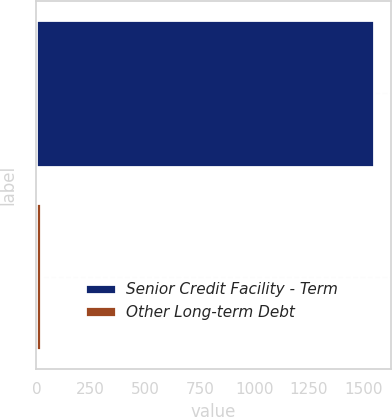<chart> <loc_0><loc_0><loc_500><loc_500><bar_chart><fcel>Senior Credit Facility - Term<fcel>Other Long-term Debt<nl><fcel>1549.1<fcel>22.6<nl></chart> 